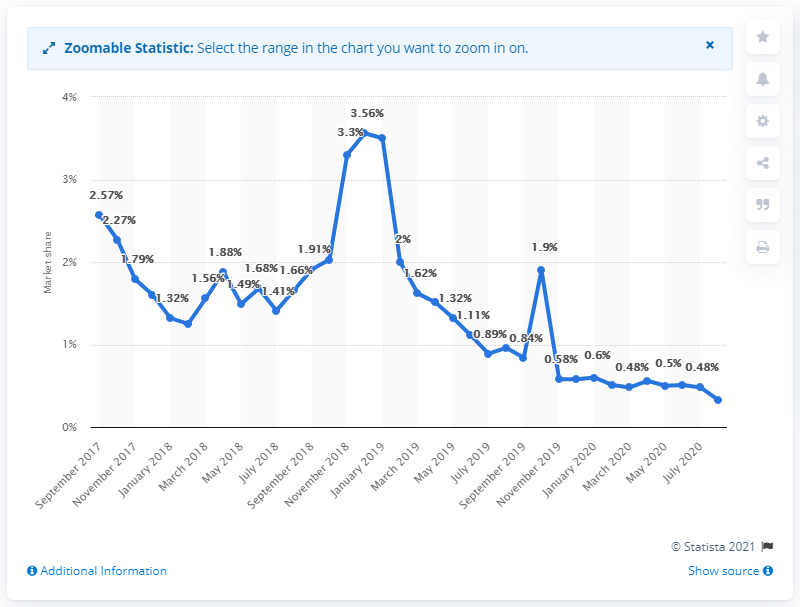Give some essential details in this illustration. In August 2020, Bing's share of the mobile search engine market in India was 0.33%. 